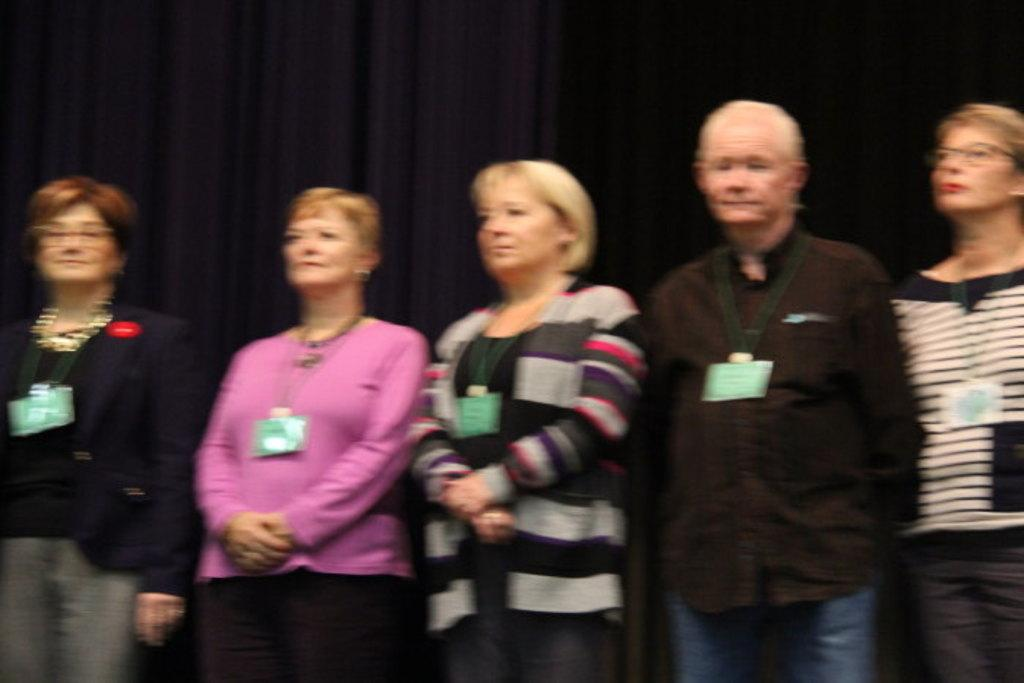How many people are in the image? There is a group of people in the image, but the exact number is not specified. What are the people in the image doing? The people are standing in the image. What can be seen in the background of the image? There is a black curtain in the background of the image. What type of acoustics can be heard in the library in the image? There is no mention of a library or any sounds in the image, so it's not possible to determine the acoustics. 